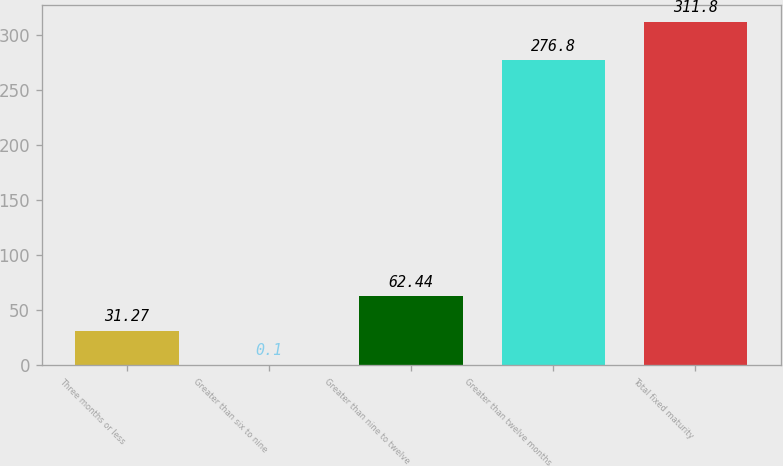Convert chart to OTSL. <chart><loc_0><loc_0><loc_500><loc_500><bar_chart><fcel>Three months or less<fcel>Greater than six to nine<fcel>Greater than nine to twelve<fcel>Greater than twelve months<fcel>Total fixed maturity<nl><fcel>31.27<fcel>0.1<fcel>62.44<fcel>276.8<fcel>311.8<nl></chart> 